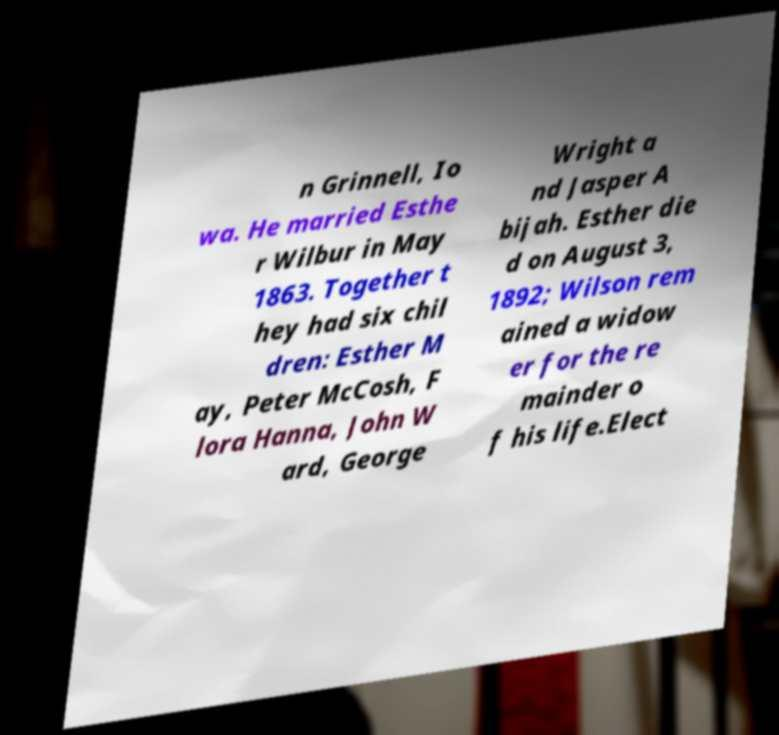Can you read and provide the text displayed in the image?This photo seems to have some interesting text. Can you extract and type it out for me? n Grinnell, Io wa. He married Esthe r Wilbur in May 1863. Together t hey had six chil dren: Esther M ay, Peter McCosh, F lora Hanna, John W ard, George Wright a nd Jasper A bijah. Esther die d on August 3, 1892; Wilson rem ained a widow er for the re mainder o f his life.Elect 